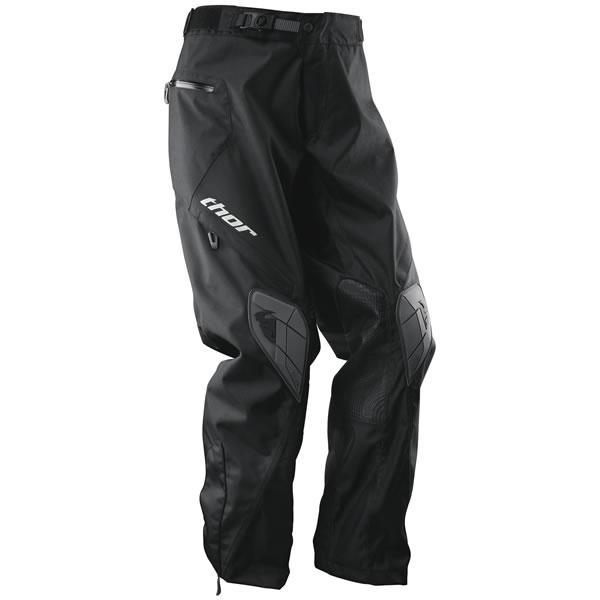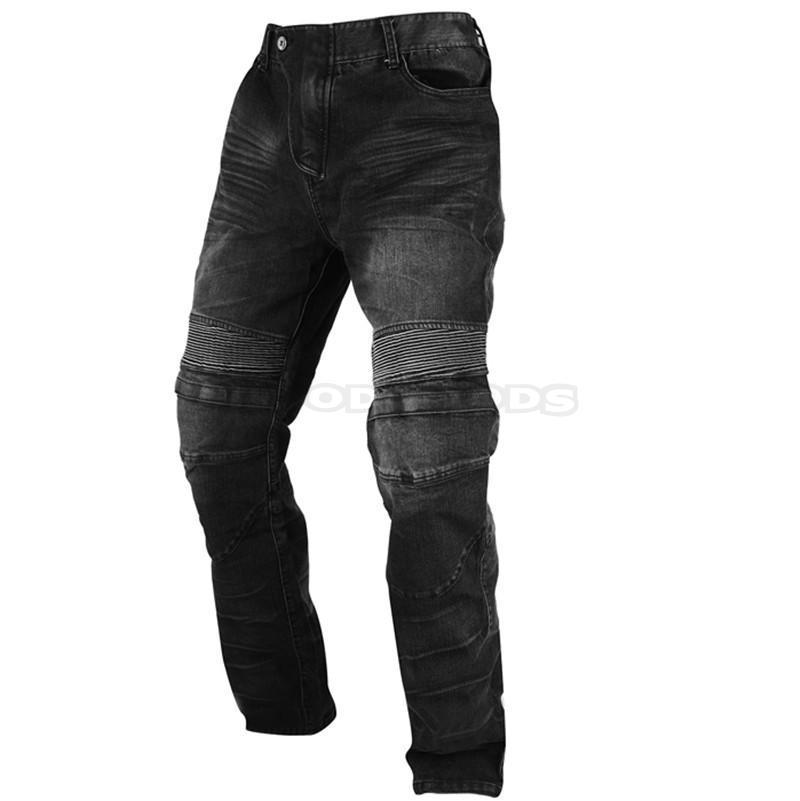The first image is the image on the left, the second image is the image on the right. Analyze the images presented: Is the assertion "there are full legged pants in the image pair" valid? Answer yes or no. Yes. 